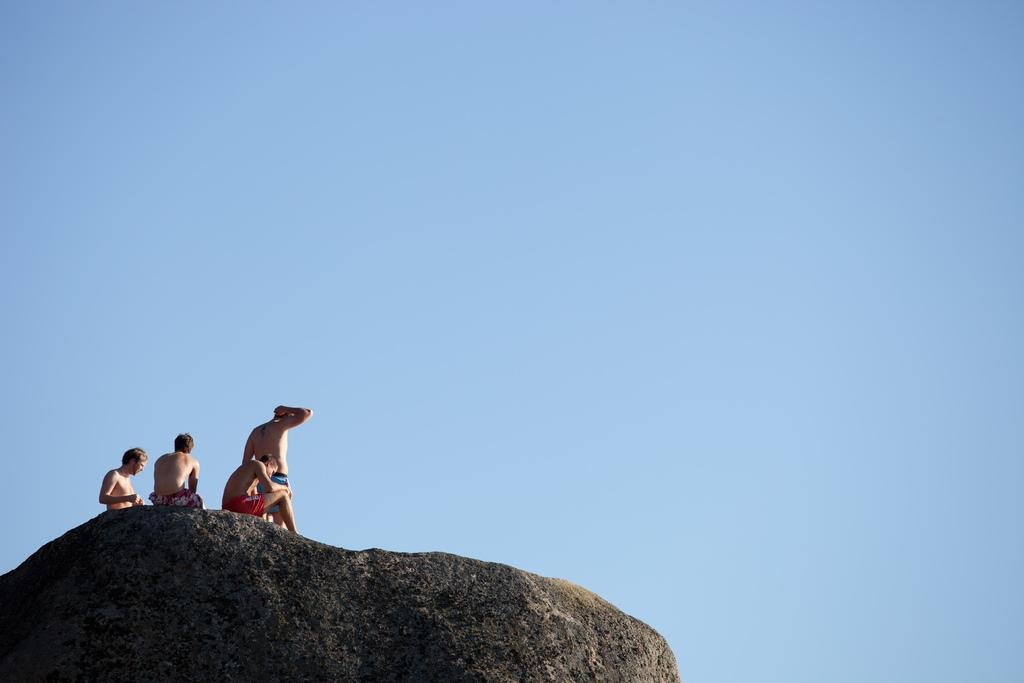How many people are in the image? There are four men in the image. What are the men standing on? The men are standing on a stone. What can be seen in the background of the image? There is sky visible in the background of the image. What type of apple is being held by one of the men in the image? There is no apple present in the image; the men are not holding any objects. 